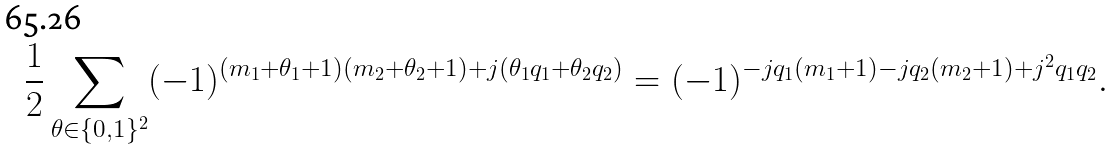Convert formula to latex. <formula><loc_0><loc_0><loc_500><loc_500>\frac { 1 } { 2 } \sum _ { \theta \in \{ 0 , 1 \} ^ { 2 } } ( - 1 ) ^ { ( m _ { 1 } + \theta _ { 1 } + 1 ) ( m _ { 2 } + \theta _ { 2 } + 1 ) + j ( \theta _ { 1 } q _ { 1 } + \theta _ { 2 } q _ { 2 } ) } = ( - 1 ) ^ { - j q _ { 1 } ( m _ { 1 } + 1 ) - j q _ { 2 } ( m _ { 2 } + 1 ) + j ^ { 2 } q _ { 1 } q _ { 2 } } .</formula> 